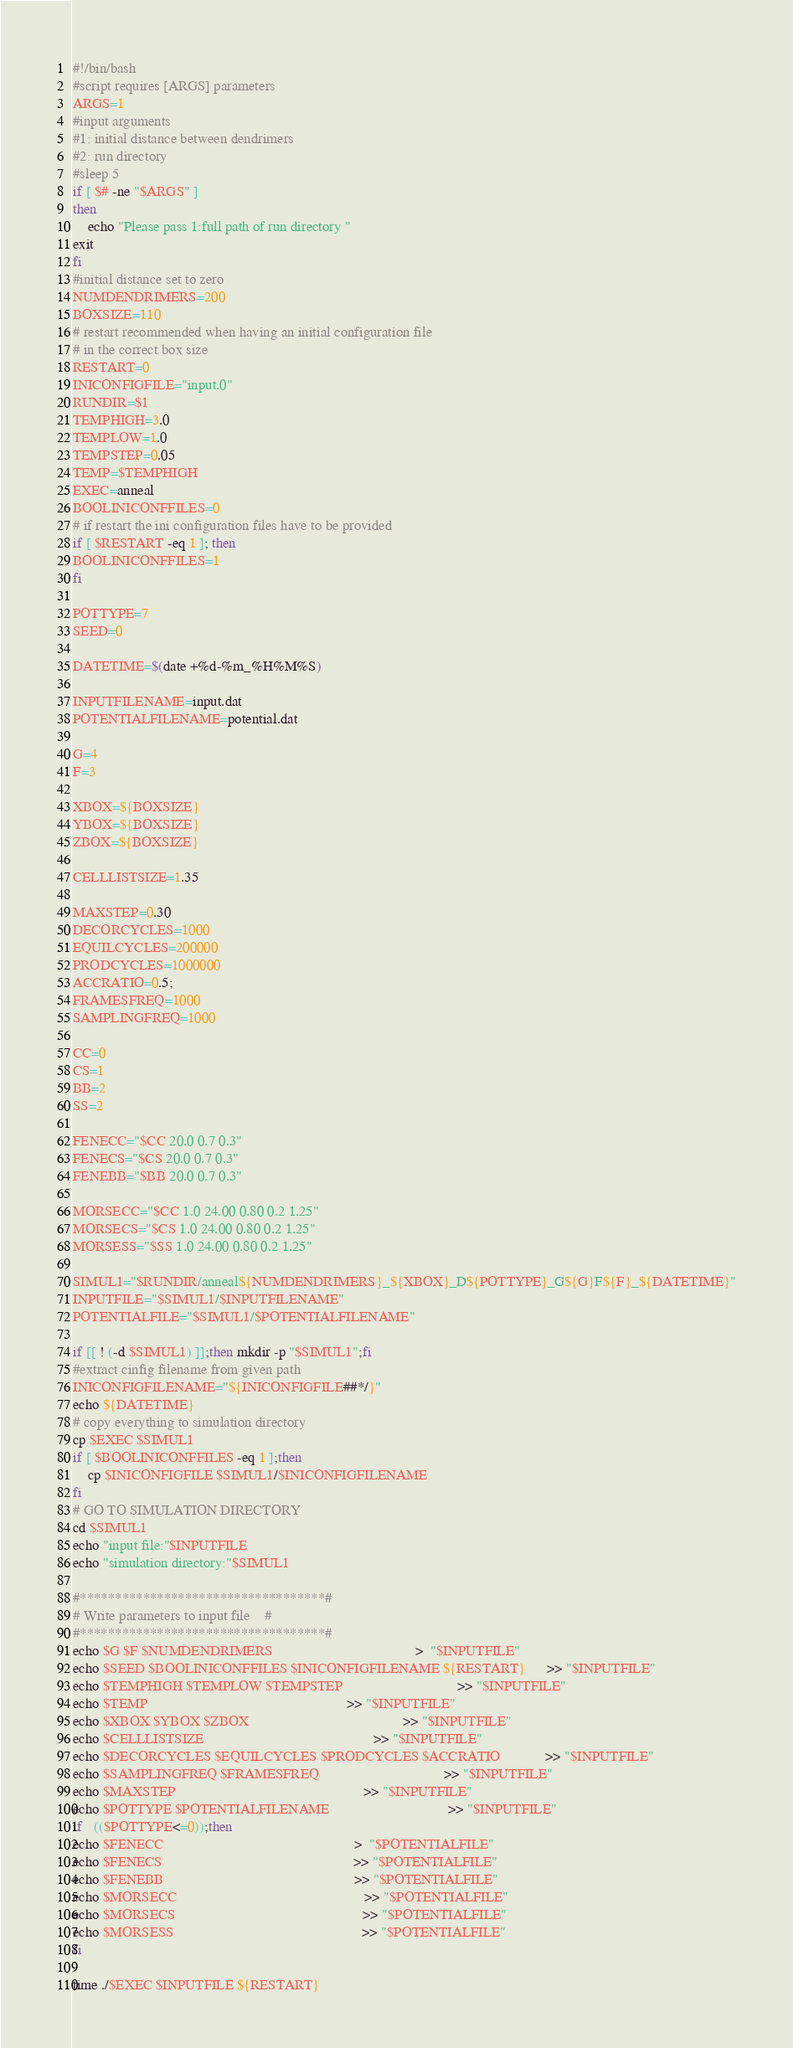<code> <loc_0><loc_0><loc_500><loc_500><_Bash_>#!/bin/bash
#script requires [ARGS] parameters
ARGS=1 
#input arguments
#1: initial distance between dendrimers
#2: run directory
#sleep 5
if [ $# -ne "$ARGS" ]
then
	echo "Please pass 1:full path of run directory "
exit
fi
#initial distance set to zero
NUMDENDRIMERS=200
BOXSIZE=110
# restart recommended when having an initial configuration file
# in the correct box size
RESTART=0
INICONFIGFILE="input.0"
RUNDIR=$1
TEMPHIGH=3.0
TEMPLOW=1.0
TEMPSTEP=0.05
TEMP=$TEMPHIGH
EXEC=anneal
BOOLINICONFFILES=0
# if restart the ini configuration files have to be provided
if [ $RESTART -eq 1 ]; then
BOOLINICONFFILES=1
fi

POTTYPE=7
SEED=0

DATETIME=$(date +%d-%m_%H%M%S)

INPUTFILENAME=input.dat
POTENTIALFILENAME=potential.dat

G=4
F=3

XBOX=${BOXSIZE}
YBOX=${BOXSIZE}
ZBOX=${BOXSIZE}

CELLLISTSIZE=1.35

MAXSTEP=0.30
DECORCYCLES=1000
EQUILCYCLES=200000
PRODCYCLES=1000000
ACCRATIO=0.5;
FRAMESFREQ=1000
SAMPLINGFREQ=1000

CC=0 
CS=1
BB=2
SS=2

FENECC="$CC 20.0 0.7 0.3"
FENECS="$CS 20.0 0.7 0.3"
FENEBB="$BB 20.0 0.7 0.3"

MORSECC="$CC 1.0 24.00 0.80 0.2 1.25"
MORSECS="$CS 1.0 24.00 0.80 0.2 1.25"
MORSESS="$SS 1.0 24.00 0.80 0.2 1.25"

SIMUL1="$RUNDIR/anneal${NUMDENDRIMERS}_${XBOX}_D${POTTYPE}_G${G}F${F}_${DATETIME}"
INPUTFILE="$SIMUL1/$INPUTFILENAME"
POTENTIALFILE="$SIMUL1/$POTENTIALFILENAME"

if [[ ! (-d $SIMUL1) ]];then mkdir -p "$SIMUL1";fi
#extract cinfig filename from given path
INICONFIGFILENAME="${INICONFIGFILE##*/}"
echo ${DATETIME}
# copy everything to simulation directory
cp $EXEC $SIMUL1
if [ $BOOLINICONFFILES -eq 1 ];then 
	cp $INICONFIGFILE $SIMUL1/$INICONFIGFILENAME
fi
# GO TO SIMULATION DIRECTORY
cd $SIMUL1
echo "input file:"$INPUTFILE
echo "simulation directory:"$SIMUL1

#***********************************#
# Write parameters to input file    #
#***********************************#
echo $G $F $NUMDENDRIMERS                                       >  "$INPUTFILE" 
echo $SEED $BOOLINICONFFILES $INICONFIGFILENAME ${RESTART}      >> "$INPUTFILE"
echo $TEMPHIGH $TEMPLOW $TEMPSTEP                               >> "$INPUTFILE" 
echo $TEMP                                                      >> "$INPUTFILE"
echo $XBOX $YBOX $ZBOX                                          >> "$INPUTFILE"
echo $CELLLISTSIZE                                              >> "$INPUTFILE"
echo $DECORCYCLES $EQUILCYCLES $PRODCYCLES $ACCRATIO            >> "$INPUTFILE"
echo $SAMPLINGFREQ $FRAMESFREQ                                  >> "$INPUTFILE"
echo $MAXSTEP                                                   >> "$INPUTFILE"
echo $POTTYPE $POTENTIALFILENAME                                >> "$INPUTFILE"
if   (($POTTYPE<=0));then
echo $FENECC                                                    >  "$POTENTIALFILE"
echo $FENECS                                                    >> "$POTENTIALFILE"
echo $FENEBB                                                    >> "$POTENTIALFILE"
echo $MORSECC                                                   >> "$POTENTIALFILE"
echo $MORSECS                                                   >> "$POTENTIALFILE"
echo $MORSESS                                                   >> "$POTENTIALFILE"
fi

time ./$EXEC $INPUTFILE ${RESTART}
</code> 